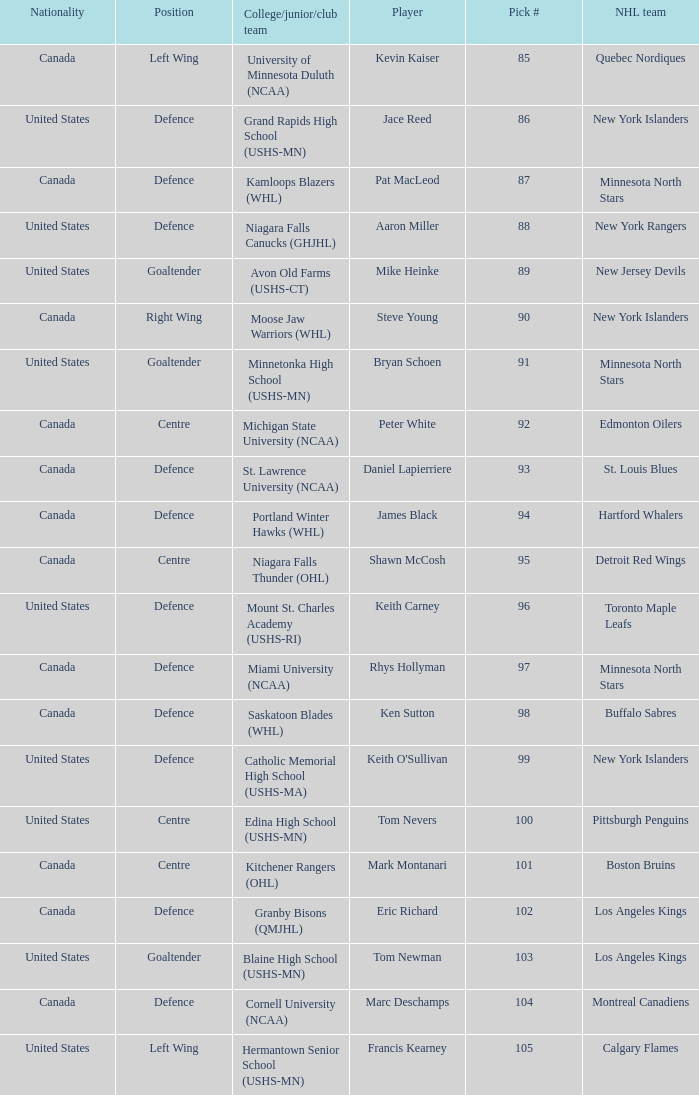Which pick number did marc deschamps hold in the draft? 104.0. 